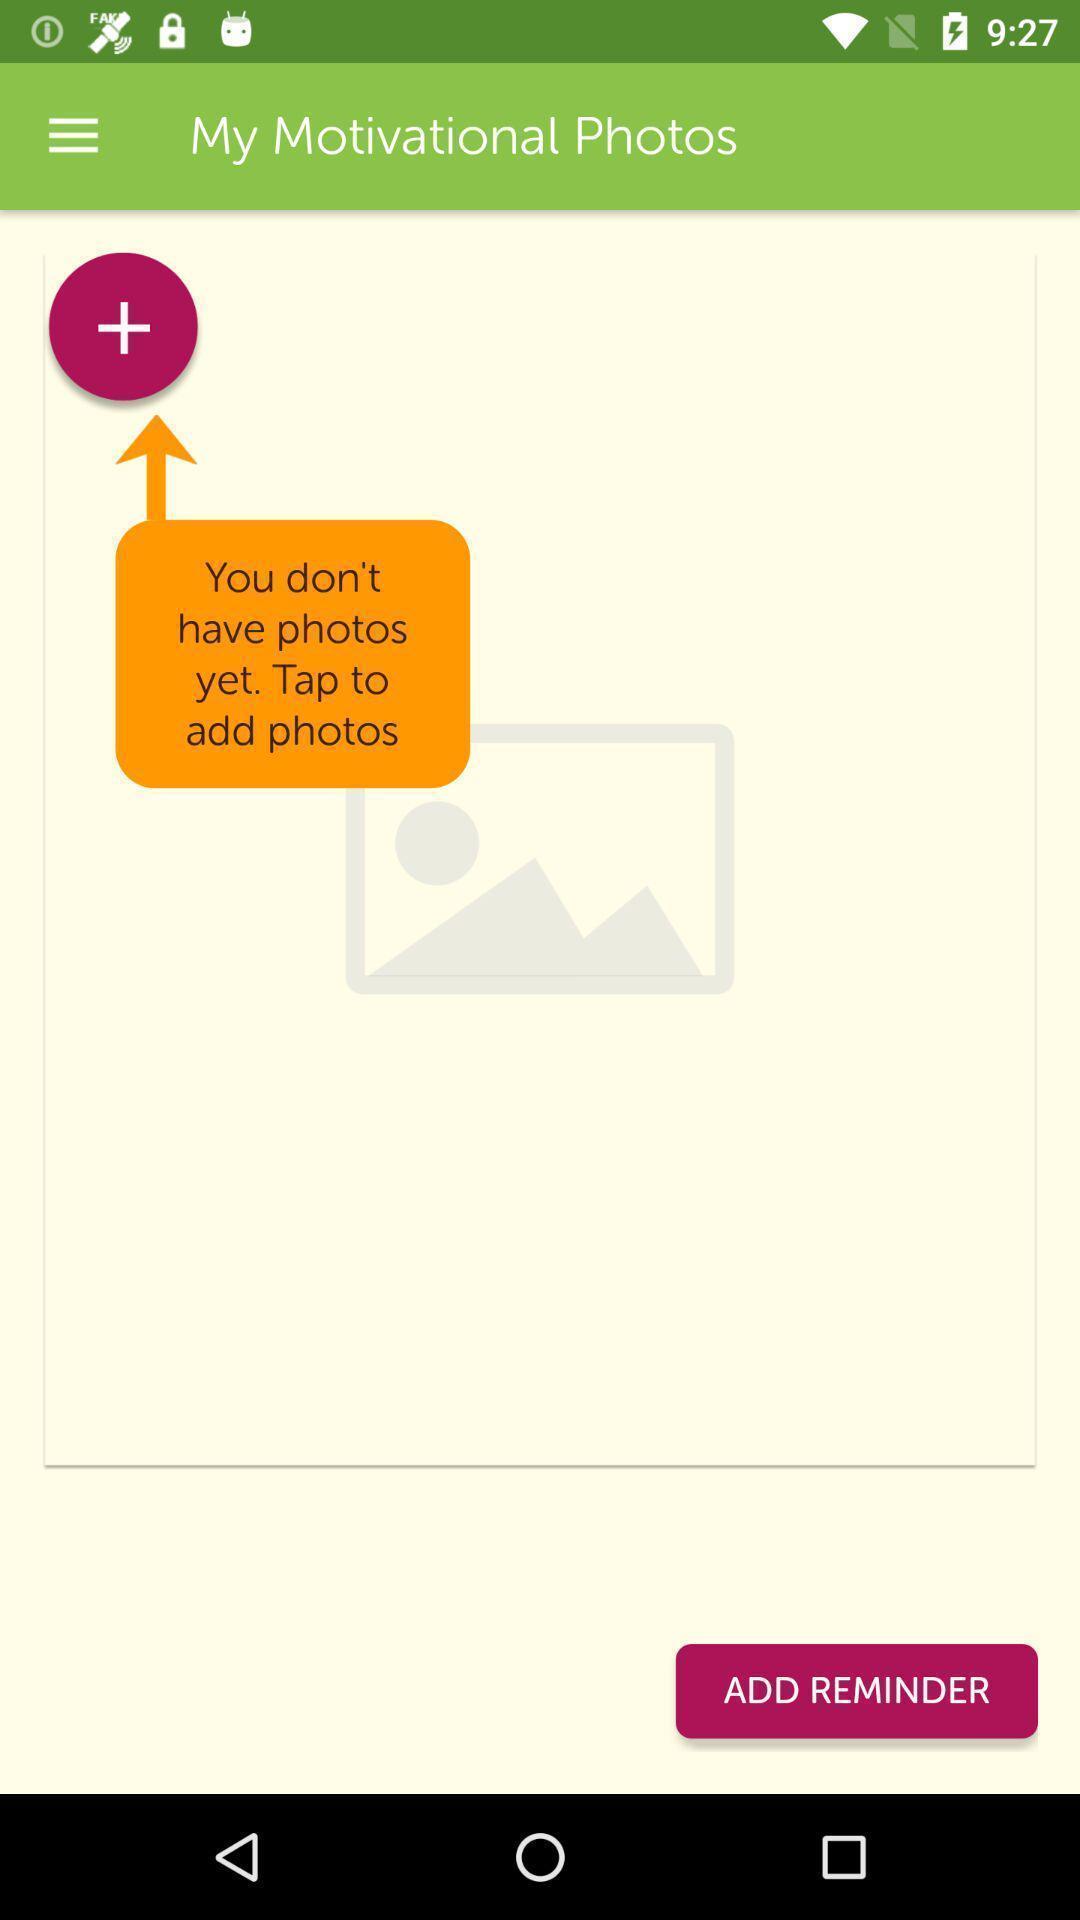Summarize the information in this screenshot. Page displays photos to add with multiple options. 